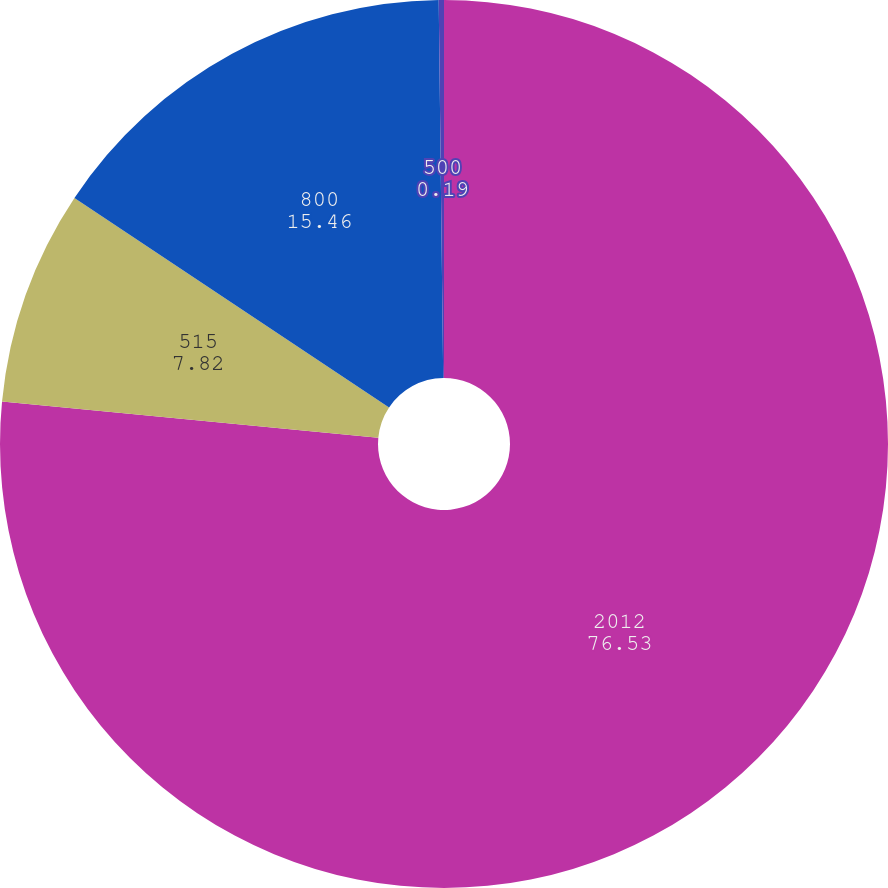Convert chart. <chart><loc_0><loc_0><loc_500><loc_500><pie_chart><fcel>2012<fcel>515<fcel>800<fcel>500<nl><fcel>76.53%<fcel>7.82%<fcel>15.46%<fcel>0.19%<nl></chart> 